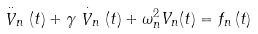Convert formula to latex. <formula><loc_0><loc_0><loc_500><loc_500>\stackrel { \cdot \cdot } { V } _ { n } ( t ) + \gamma \stackrel { \cdot } { V } _ { n } ( t ) + \omega _ { n } ^ { 2 } V _ { n } ( t ) = f _ { n } \left ( t \right )</formula> 